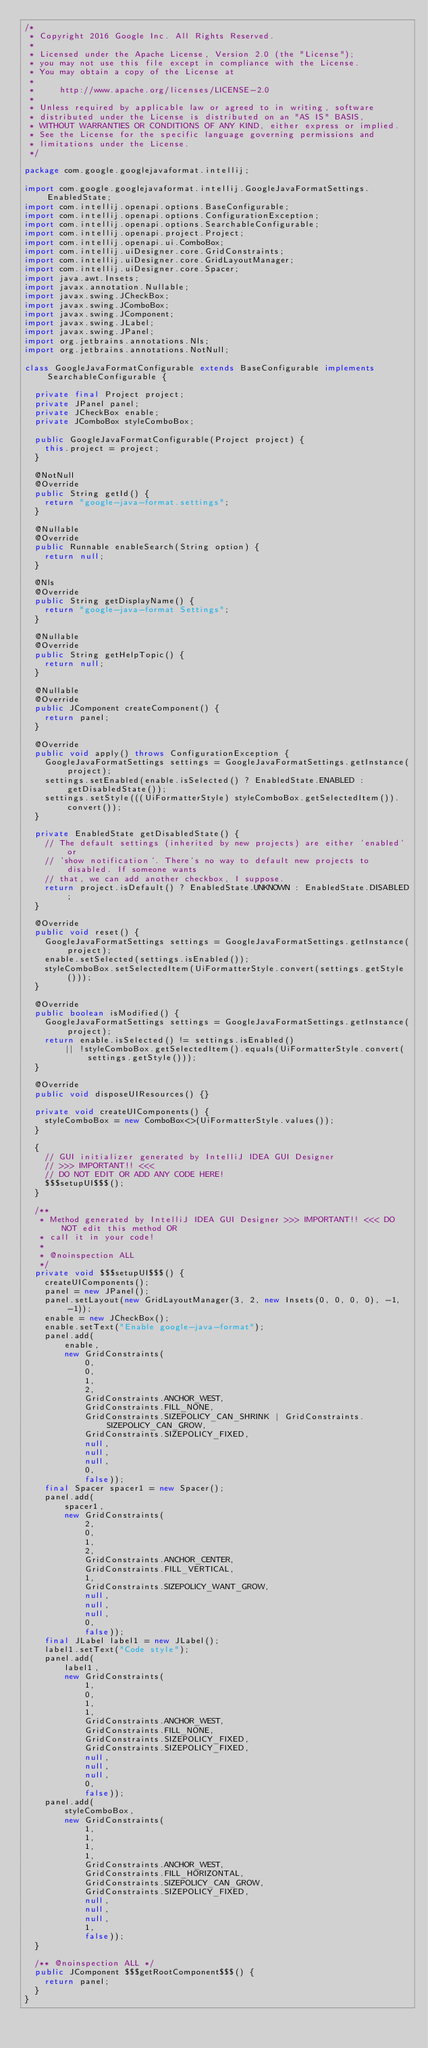Convert code to text. <code><loc_0><loc_0><loc_500><loc_500><_Java_>/*
 * Copyright 2016 Google Inc. All Rights Reserved.
 *
 * Licensed under the Apache License, Version 2.0 (the "License");
 * you may not use this file except in compliance with the License.
 * You may obtain a copy of the License at
 *
 *     http://www.apache.org/licenses/LICENSE-2.0
 *
 * Unless required by applicable law or agreed to in writing, software
 * distributed under the License is distributed on an "AS IS" BASIS,
 * WITHOUT WARRANTIES OR CONDITIONS OF ANY KIND, either express or implied.
 * See the License for the specific language governing permissions and
 * limitations under the License.
 */

package com.google.googlejavaformat.intellij;

import com.google.googlejavaformat.intellij.GoogleJavaFormatSettings.EnabledState;
import com.intellij.openapi.options.BaseConfigurable;
import com.intellij.openapi.options.ConfigurationException;
import com.intellij.openapi.options.SearchableConfigurable;
import com.intellij.openapi.project.Project;
import com.intellij.openapi.ui.ComboBox;
import com.intellij.uiDesigner.core.GridConstraints;
import com.intellij.uiDesigner.core.GridLayoutManager;
import com.intellij.uiDesigner.core.Spacer;
import java.awt.Insets;
import javax.annotation.Nullable;
import javax.swing.JCheckBox;
import javax.swing.JComboBox;
import javax.swing.JComponent;
import javax.swing.JLabel;
import javax.swing.JPanel;
import org.jetbrains.annotations.Nls;
import org.jetbrains.annotations.NotNull;

class GoogleJavaFormatConfigurable extends BaseConfigurable implements SearchableConfigurable {

  private final Project project;
  private JPanel panel;
  private JCheckBox enable;
  private JComboBox styleComboBox;

  public GoogleJavaFormatConfigurable(Project project) {
    this.project = project;
  }

  @NotNull
  @Override
  public String getId() {
    return "google-java-format.settings";
  }

  @Nullable
  @Override
  public Runnable enableSearch(String option) {
    return null;
  }

  @Nls
  @Override
  public String getDisplayName() {
    return "google-java-format Settings";
  }

  @Nullable
  @Override
  public String getHelpTopic() {
    return null;
  }

  @Nullable
  @Override
  public JComponent createComponent() {
    return panel;
  }

  @Override
  public void apply() throws ConfigurationException {
    GoogleJavaFormatSettings settings = GoogleJavaFormatSettings.getInstance(project);
    settings.setEnabled(enable.isSelected() ? EnabledState.ENABLED : getDisabledState());
    settings.setStyle(((UiFormatterStyle) styleComboBox.getSelectedItem()).convert());
  }

  private EnabledState getDisabledState() {
    // The default settings (inherited by new projects) are either 'enabled' or
    // 'show notification'. There's no way to default new projects to disabled. If someone wants
    // that, we can add another checkbox, I suppose.
    return project.isDefault() ? EnabledState.UNKNOWN : EnabledState.DISABLED;
  }

  @Override
  public void reset() {
    GoogleJavaFormatSettings settings = GoogleJavaFormatSettings.getInstance(project);
    enable.setSelected(settings.isEnabled());
    styleComboBox.setSelectedItem(UiFormatterStyle.convert(settings.getStyle()));
  }

  @Override
  public boolean isModified() {
    GoogleJavaFormatSettings settings = GoogleJavaFormatSettings.getInstance(project);
    return enable.isSelected() != settings.isEnabled()
        || !styleComboBox.getSelectedItem().equals(UiFormatterStyle.convert(settings.getStyle()));
  }

  @Override
  public void disposeUIResources() {}

  private void createUIComponents() {
    styleComboBox = new ComboBox<>(UiFormatterStyle.values());
  }

  {
    // GUI initializer generated by IntelliJ IDEA GUI Designer
    // >>> IMPORTANT!! <<<
    // DO NOT EDIT OR ADD ANY CODE HERE!
    $$$setupUI$$$();
  }

  /**
   * Method generated by IntelliJ IDEA GUI Designer >>> IMPORTANT!! <<< DO NOT edit this method OR
   * call it in your code!
   *
   * @noinspection ALL
   */
  private void $$$setupUI$$$() {
    createUIComponents();
    panel = new JPanel();
    panel.setLayout(new GridLayoutManager(3, 2, new Insets(0, 0, 0, 0), -1, -1));
    enable = new JCheckBox();
    enable.setText("Enable google-java-format");
    panel.add(
        enable,
        new GridConstraints(
            0,
            0,
            1,
            2,
            GridConstraints.ANCHOR_WEST,
            GridConstraints.FILL_NONE,
            GridConstraints.SIZEPOLICY_CAN_SHRINK | GridConstraints.SIZEPOLICY_CAN_GROW,
            GridConstraints.SIZEPOLICY_FIXED,
            null,
            null,
            null,
            0,
            false));
    final Spacer spacer1 = new Spacer();
    panel.add(
        spacer1,
        new GridConstraints(
            2,
            0,
            1,
            2,
            GridConstraints.ANCHOR_CENTER,
            GridConstraints.FILL_VERTICAL,
            1,
            GridConstraints.SIZEPOLICY_WANT_GROW,
            null,
            null,
            null,
            0,
            false));
    final JLabel label1 = new JLabel();
    label1.setText("Code style");
    panel.add(
        label1,
        new GridConstraints(
            1,
            0,
            1,
            1,
            GridConstraints.ANCHOR_WEST,
            GridConstraints.FILL_NONE,
            GridConstraints.SIZEPOLICY_FIXED,
            GridConstraints.SIZEPOLICY_FIXED,
            null,
            null,
            null,
            0,
            false));
    panel.add(
        styleComboBox,
        new GridConstraints(
            1,
            1,
            1,
            1,
            GridConstraints.ANCHOR_WEST,
            GridConstraints.FILL_HORIZONTAL,
            GridConstraints.SIZEPOLICY_CAN_GROW,
            GridConstraints.SIZEPOLICY_FIXED,
            null,
            null,
            null,
            1,
            false));
  }

  /** @noinspection ALL */
  public JComponent $$$getRootComponent$$$() {
    return panel;
  }
}
</code> 